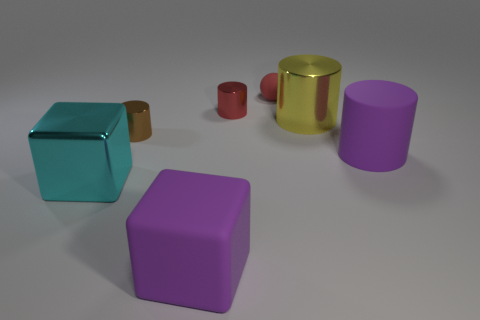Subtract all yellow cylinders. How many cylinders are left? 3 Add 2 tiny red cylinders. How many objects exist? 9 Subtract all cubes. How many objects are left? 5 Subtract 1 spheres. How many spheres are left? 0 Subtract all yellow cylinders. How many cylinders are left? 3 Subtract 0 red cubes. How many objects are left? 7 Subtract all gray blocks. Subtract all blue spheres. How many blocks are left? 2 Subtract all blue balls. How many blue blocks are left? 0 Subtract all spheres. Subtract all red metallic objects. How many objects are left? 5 Add 3 small red metal objects. How many small red metal objects are left? 4 